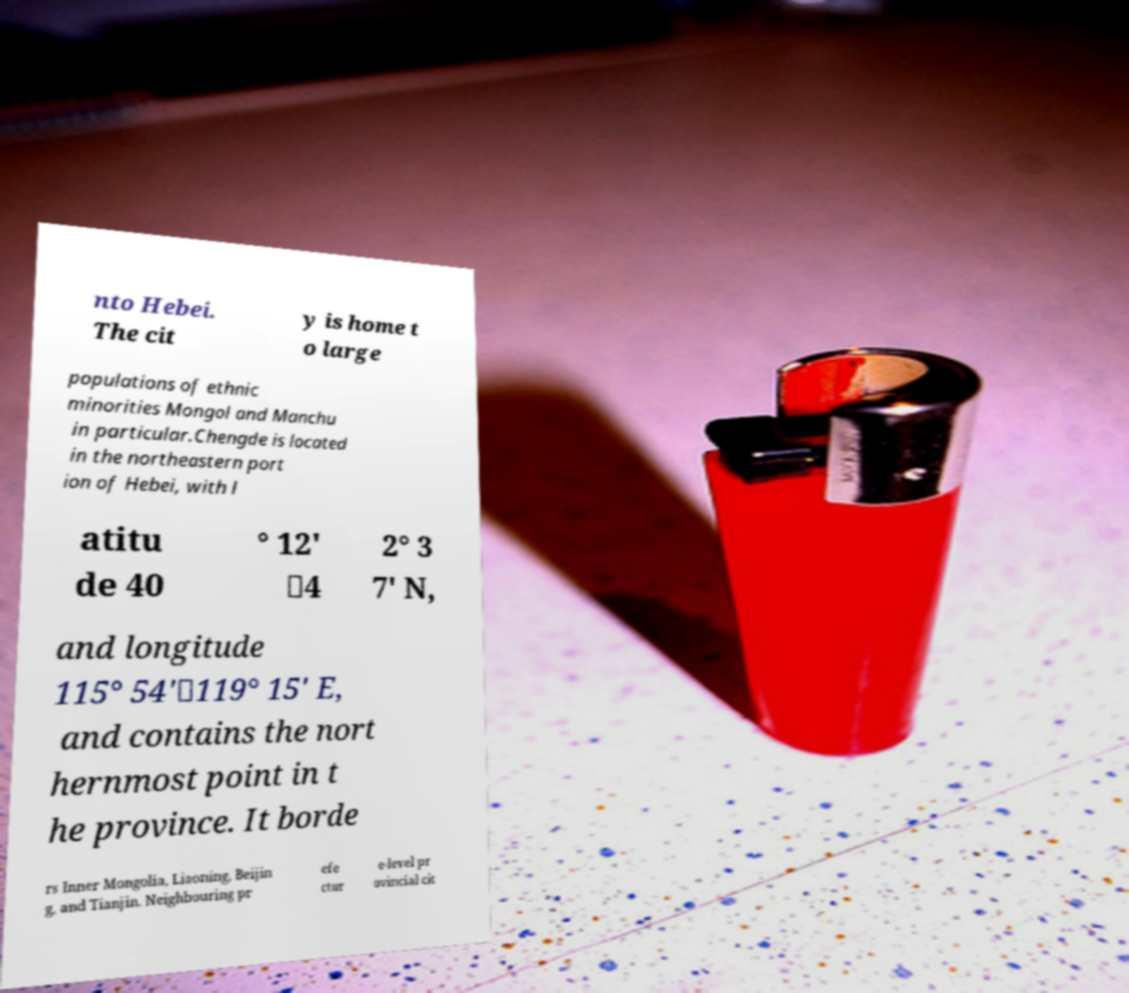I need the written content from this picture converted into text. Can you do that? nto Hebei. The cit y is home t o large populations of ethnic minorities Mongol and Manchu in particular.Chengde is located in the northeastern port ion of Hebei, with l atitu de 40 ° 12' －4 2° 3 7' N, and longitude 115° 54'－119° 15' E, and contains the nort hernmost point in t he province. It borde rs Inner Mongolia, Liaoning, Beijin g, and Tianjin. Neighbouring pr efe ctur e-level pr ovincial cit 